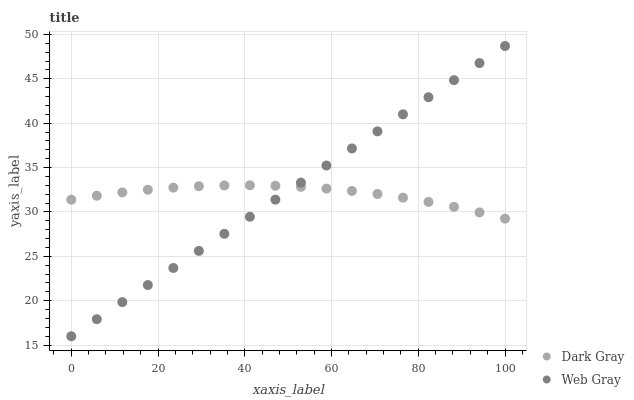Does Dark Gray have the minimum area under the curve?
Answer yes or no. Yes. Does Web Gray have the maximum area under the curve?
Answer yes or no. Yes. Does Web Gray have the minimum area under the curve?
Answer yes or no. No. Is Web Gray the smoothest?
Answer yes or no. Yes. Is Dark Gray the roughest?
Answer yes or no. Yes. Is Web Gray the roughest?
Answer yes or no. No. Does Web Gray have the lowest value?
Answer yes or no. Yes. Does Web Gray have the highest value?
Answer yes or no. Yes. Does Dark Gray intersect Web Gray?
Answer yes or no. Yes. Is Dark Gray less than Web Gray?
Answer yes or no. No. Is Dark Gray greater than Web Gray?
Answer yes or no. No. 